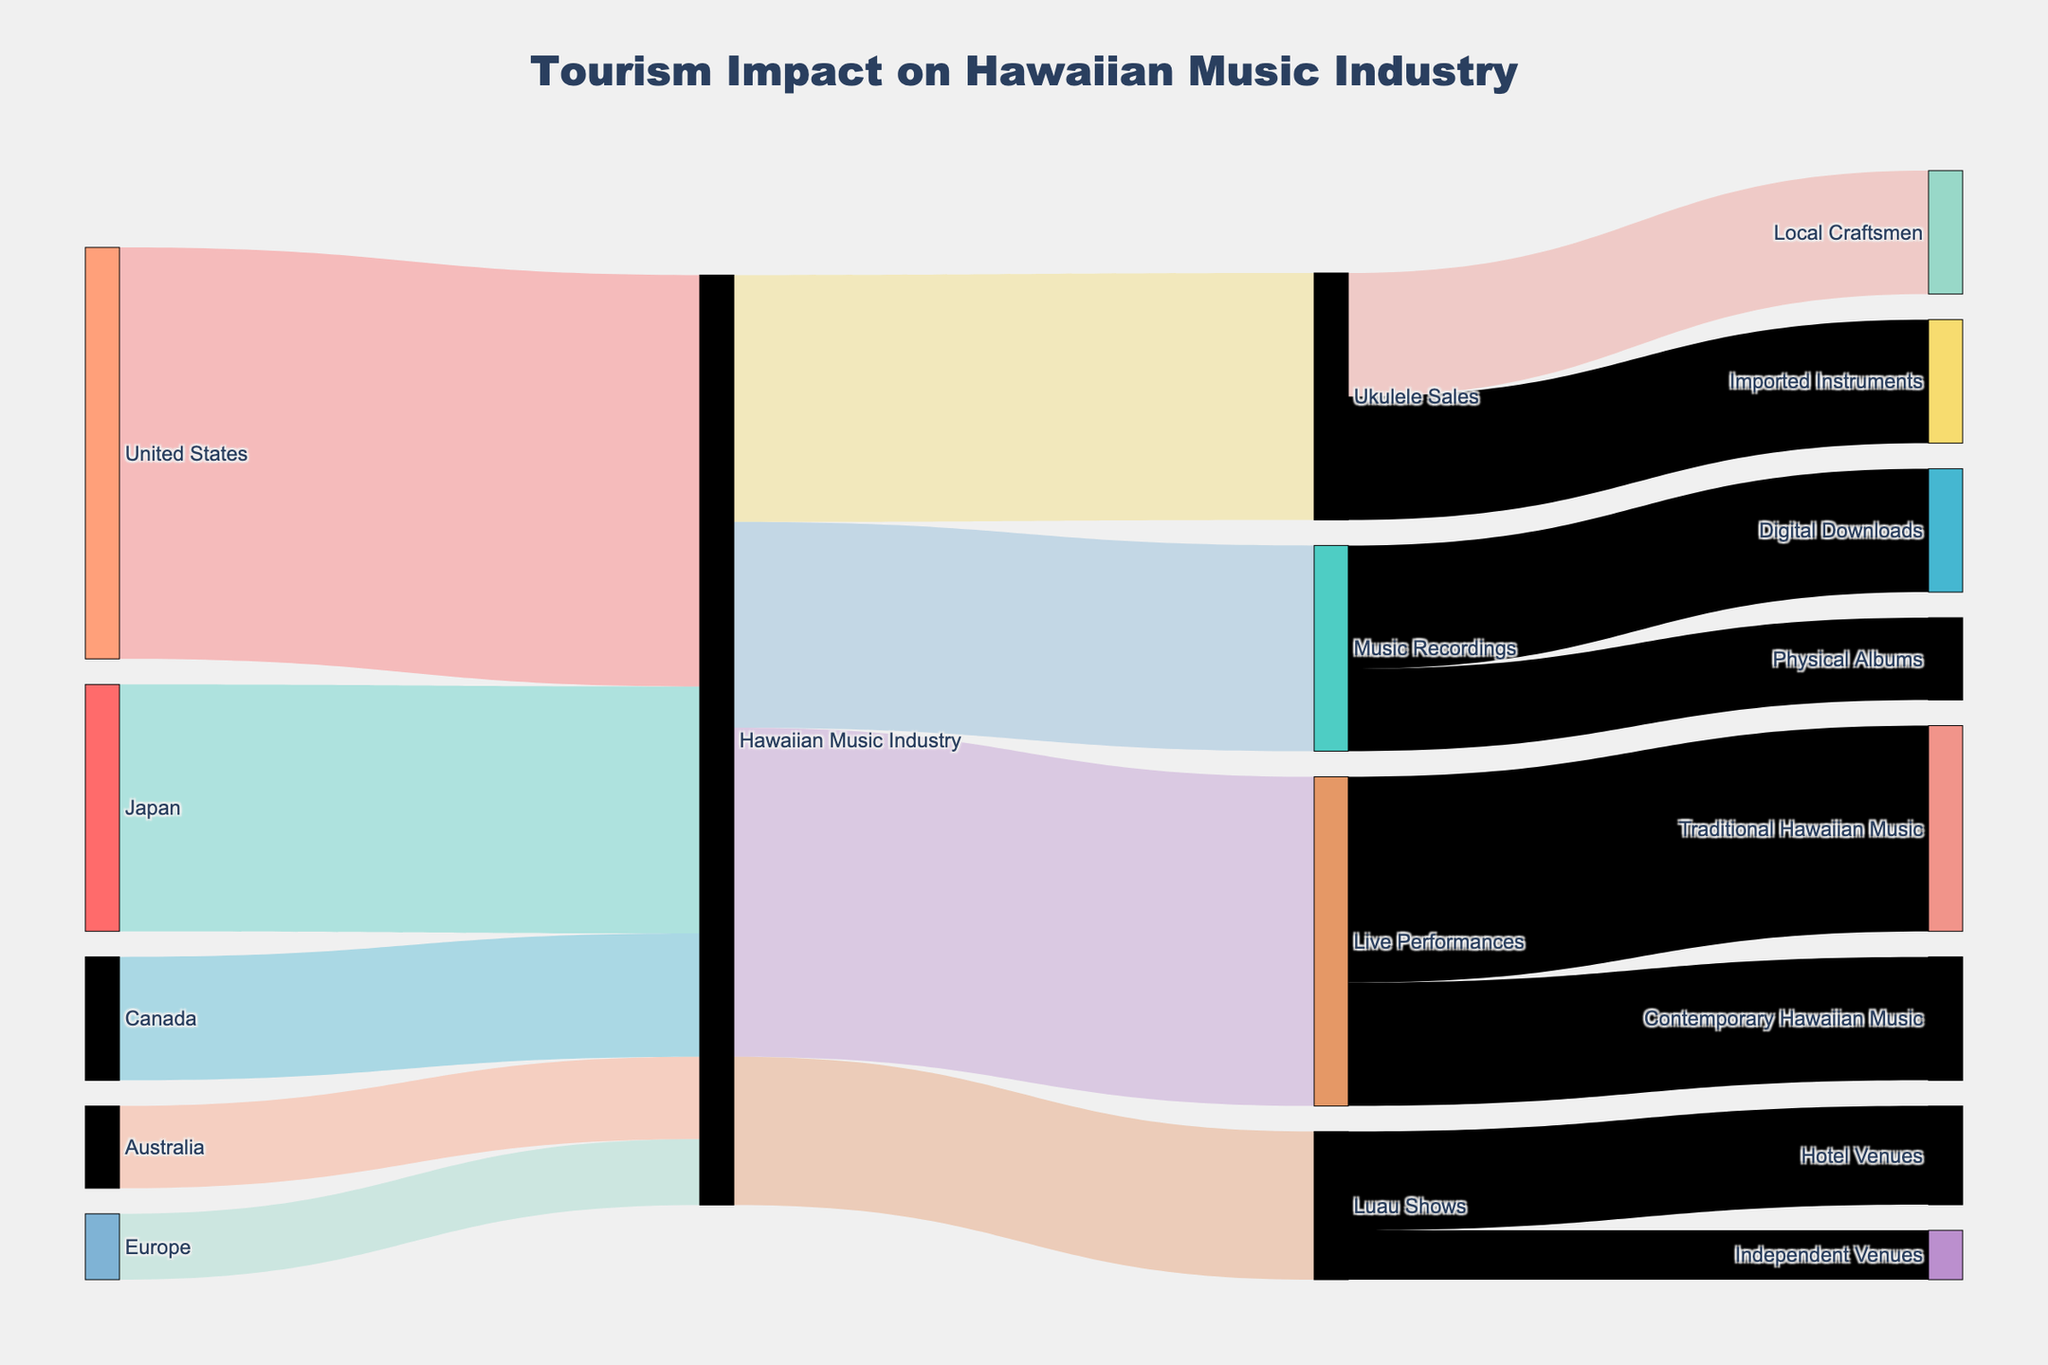Which country contributes the most to the Hawaiian Music Industry? The largest value flowing into the Hawaiian Music Industry is from the United States, with a value of 500,000.
Answer: United States What is the total economic contribution to the Hawaiian Music Industry from outside the United States? Add the values from Japan, Canada, Australia, and Europe: 300,000 + 150,000 + 100,000 + 80,000 = 630,000.
Answer: 630,000 How much does the Ukulele Sales category contribute to Local Craftsmen compared to Imported Instruments? Both Local Craftsmen and Imported Instruments receive the same value from Ukulele Sales, which is 150,000.
Answer: Equal What is the combined economic impact of Live Performances and Music Recordings on the Hawaiian Music Industry? Add the values for Live Performances and Music Recordings: 400,000 + 250,000 = 650,000.
Answer: 650,000 Which category has a larger economic impact: Luau Shows or Music Recordings? Compare the values: Luau Shows (180,000) vs. Music Recordings (250,000). Music Recordings has a larger impact.
Answer: Music Recordings What percentage of the total economic contribution to the Hawaiian Music Industry comes from Japan? First, calculate the total contribution (500,000 + 300,000 + 150,000 + 100,000 + 80,000 = 1,130,000). Japan's percentage is (300,000 / 1,130,000) * 100 ≈ 26.55%.
Answer: 26.55% How are the contributions of Live Performances divided between Traditional Hawaiian Music and Contemporary Hawaiian Music? Live Performances contribute 250,000 to Traditional Hawaiian Music and 150,000 to Contemporary Hawaiian Music.
Answer: 250,000 to Traditional, 150,000 to Contemporary What is the total value flowing into Music Recordings? Add the values of Digital Downloads and Physical Albums: 150,000 + 100,000 = 250,000.
Answer: 250,000 Which has a higher value: the economic contribution from Europe or the contribution from Live Performances to Contemporary Hawaiian Music? Compare the values: Europe (80,000) vs. Live Performances to Contemporary Hawaiian Music (150,000). Live Performances to Contemporary Hawaiian Music has a higher value.
Answer: Live Performances to Contemporary Hawaiian Music How much economic contribution does the Hawaiian Music Industry receive compared to its distribution? The Hawaiian Music Industry receives 1,130,000 (sum of values from all countries). It distributes 300,000 (Ukulele Sales) + 400,000 (Live Performances) + 250,000 (Music Recordings) + 180,000 (Luau Shows) = 1,130,000.
Answer: Equal 